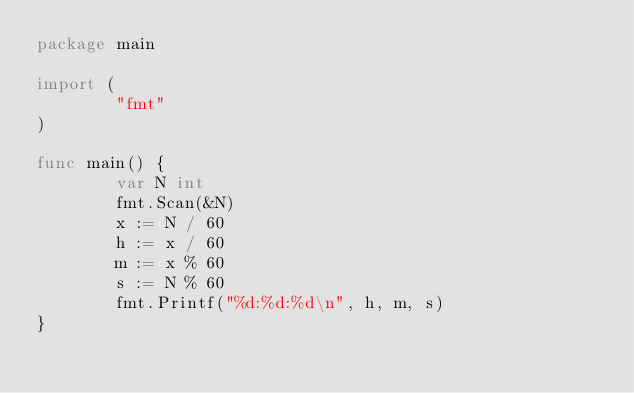Convert code to text. <code><loc_0><loc_0><loc_500><loc_500><_Go_>package main

import (
        "fmt"
)

func main() {
        var N int
        fmt.Scan(&N)
        x := N / 60
        h := x / 60
        m := x % 60
        s := N % 60
        fmt.Printf("%d:%d:%d\n", h, m, s)
}
</code> 